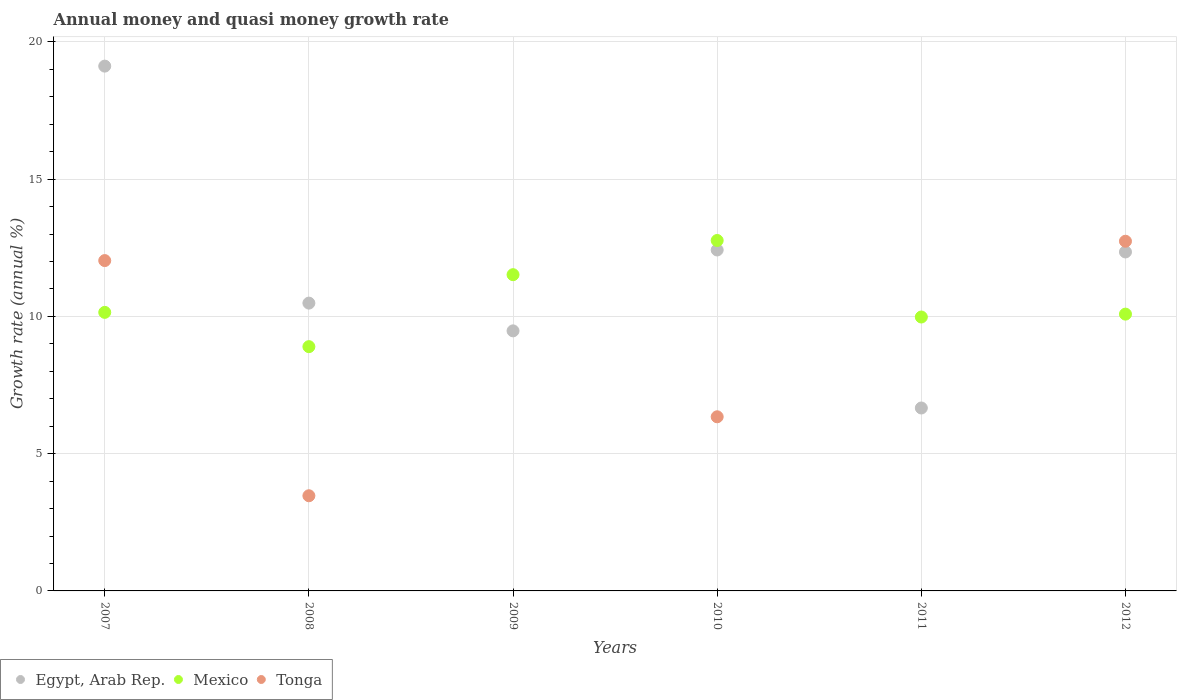Is the number of dotlines equal to the number of legend labels?
Ensure brevity in your answer.  No. What is the growth rate in Tonga in 2010?
Give a very brief answer. 6.34. Across all years, what is the maximum growth rate in Mexico?
Ensure brevity in your answer.  12.77. Across all years, what is the minimum growth rate in Mexico?
Make the answer very short. 8.9. What is the total growth rate in Tonga in the graph?
Make the answer very short. 34.58. What is the difference between the growth rate in Mexico in 2009 and that in 2012?
Provide a short and direct response. 1.44. What is the difference between the growth rate in Tonga in 2011 and the growth rate in Mexico in 2012?
Provide a succinct answer. -10.08. What is the average growth rate in Tonga per year?
Offer a terse response. 5.76. In the year 2007, what is the difference between the growth rate in Egypt, Arab Rep. and growth rate in Tonga?
Your answer should be compact. 7.08. In how many years, is the growth rate in Tonga greater than 12 %?
Ensure brevity in your answer.  2. What is the ratio of the growth rate in Mexico in 2009 to that in 2012?
Ensure brevity in your answer.  1.14. Is the growth rate in Mexico in 2007 less than that in 2008?
Offer a terse response. No. Is the difference between the growth rate in Egypt, Arab Rep. in 2007 and 2010 greater than the difference between the growth rate in Tonga in 2007 and 2010?
Provide a short and direct response. Yes. What is the difference between the highest and the second highest growth rate in Egypt, Arab Rep.?
Make the answer very short. 6.7. What is the difference between the highest and the lowest growth rate in Tonga?
Provide a succinct answer. 12.74. How many dotlines are there?
Give a very brief answer. 3. What is the difference between two consecutive major ticks on the Y-axis?
Offer a very short reply. 5. Are the values on the major ticks of Y-axis written in scientific E-notation?
Your answer should be very brief. No. Does the graph contain grids?
Make the answer very short. Yes. How are the legend labels stacked?
Give a very brief answer. Horizontal. What is the title of the graph?
Keep it short and to the point. Annual money and quasi money growth rate. Does "Greenland" appear as one of the legend labels in the graph?
Make the answer very short. No. What is the label or title of the X-axis?
Offer a very short reply. Years. What is the label or title of the Y-axis?
Provide a short and direct response. Growth rate (annual %). What is the Growth rate (annual %) in Egypt, Arab Rep. in 2007?
Make the answer very short. 19.12. What is the Growth rate (annual %) of Mexico in 2007?
Your response must be concise. 10.15. What is the Growth rate (annual %) of Tonga in 2007?
Your answer should be very brief. 12.03. What is the Growth rate (annual %) in Egypt, Arab Rep. in 2008?
Offer a very short reply. 10.49. What is the Growth rate (annual %) of Mexico in 2008?
Offer a terse response. 8.9. What is the Growth rate (annual %) in Tonga in 2008?
Your response must be concise. 3.47. What is the Growth rate (annual %) in Egypt, Arab Rep. in 2009?
Make the answer very short. 9.47. What is the Growth rate (annual %) in Mexico in 2009?
Offer a very short reply. 11.52. What is the Growth rate (annual %) of Tonga in 2009?
Keep it short and to the point. 0. What is the Growth rate (annual %) in Egypt, Arab Rep. in 2010?
Provide a succinct answer. 12.42. What is the Growth rate (annual %) of Mexico in 2010?
Give a very brief answer. 12.77. What is the Growth rate (annual %) in Tonga in 2010?
Your response must be concise. 6.34. What is the Growth rate (annual %) in Egypt, Arab Rep. in 2011?
Offer a terse response. 6.66. What is the Growth rate (annual %) of Mexico in 2011?
Your answer should be very brief. 9.98. What is the Growth rate (annual %) of Egypt, Arab Rep. in 2012?
Your response must be concise. 12.35. What is the Growth rate (annual %) in Mexico in 2012?
Give a very brief answer. 10.08. What is the Growth rate (annual %) in Tonga in 2012?
Your response must be concise. 12.74. Across all years, what is the maximum Growth rate (annual %) of Egypt, Arab Rep.?
Your answer should be very brief. 19.12. Across all years, what is the maximum Growth rate (annual %) of Mexico?
Give a very brief answer. 12.77. Across all years, what is the maximum Growth rate (annual %) in Tonga?
Provide a succinct answer. 12.74. Across all years, what is the minimum Growth rate (annual %) in Egypt, Arab Rep.?
Your answer should be compact. 6.66. Across all years, what is the minimum Growth rate (annual %) of Mexico?
Your answer should be very brief. 8.9. Across all years, what is the minimum Growth rate (annual %) of Tonga?
Your response must be concise. 0. What is the total Growth rate (annual %) of Egypt, Arab Rep. in the graph?
Provide a short and direct response. 70.51. What is the total Growth rate (annual %) of Mexico in the graph?
Provide a succinct answer. 63.4. What is the total Growth rate (annual %) in Tonga in the graph?
Ensure brevity in your answer.  34.58. What is the difference between the Growth rate (annual %) in Egypt, Arab Rep. in 2007 and that in 2008?
Provide a succinct answer. 8.63. What is the difference between the Growth rate (annual %) in Mexico in 2007 and that in 2008?
Provide a succinct answer. 1.25. What is the difference between the Growth rate (annual %) of Tonga in 2007 and that in 2008?
Ensure brevity in your answer.  8.57. What is the difference between the Growth rate (annual %) in Egypt, Arab Rep. in 2007 and that in 2009?
Your answer should be compact. 9.65. What is the difference between the Growth rate (annual %) in Mexico in 2007 and that in 2009?
Your answer should be compact. -1.37. What is the difference between the Growth rate (annual %) in Egypt, Arab Rep. in 2007 and that in 2010?
Your response must be concise. 6.7. What is the difference between the Growth rate (annual %) of Mexico in 2007 and that in 2010?
Make the answer very short. -2.62. What is the difference between the Growth rate (annual %) of Tonga in 2007 and that in 2010?
Offer a terse response. 5.69. What is the difference between the Growth rate (annual %) of Egypt, Arab Rep. in 2007 and that in 2011?
Your answer should be very brief. 12.45. What is the difference between the Growth rate (annual %) of Mexico in 2007 and that in 2011?
Give a very brief answer. 0.17. What is the difference between the Growth rate (annual %) of Egypt, Arab Rep. in 2007 and that in 2012?
Give a very brief answer. 6.77. What is the difference between the Growth rate (annual %) in Mexico in 2007 and that in 2012?
Keep it short and to the point. 0.06. What is the difference between the Growth rate (annual %) in Tonga in 2007 and that in 2012?
Your response must be concise. -0.7. What is the difference between the Growth rate (annual %) in Egypt, Arab Rep. in 2008 and that in 2009?
Keep it short and to the point. 1.01. What is the difference between the Growth rate (annual %) in Mexico in 2008 and that in 2009?
Provide a succinct answer. -2.62. What is the difference between the Growth rate (annual %) in Egypt, Arab Rep. in 2008 and that in 2010?
Your answer should be compact. -1.94. What is the difference between the Growth rate (annual %) in Mexico in 2008 and that in 2010?
Your response must be concise. -3.87. What is the difference between the Growth rate (annual %) of Tonga in 2008 and that in 2010?
Keep it short and to the point. -2.88. What is the difference between the Growth rate (annual %) of Egypt, Arab Rep. in 2008 and that in 2011?
Give a very brief answer. 3.82. What is the difference between the Growth rate (annual %) in Mexico in 2008 and that in 2011?
Offer a very short reply. -1.08. What is the difference between the Growth rate (annual %) of Egypt, Arab Rep. in 2008 and that in 2012?
Your answer should be compact. -1.86. What is the difference between the Growth rate (annual %) of Mexico in 2008 and that in 2012?
Make the answer very short. -1.19. What is the difference between the Growth rate (annual %) of Tonga in 2008 and that in 2012?
Provide a short and direct response. -9.27. What is the difference between the Growth rate (annual %) of Egypt, Arab Rep. in 2009 and that in 2010?
Offer a terse response. -2.95. What is the difference between the Growth rate (annual %) in Mexico in 2009 and that in 2010?
Your response must be concise. -1.25. What is the difference between the Growth rate (annual %) in Egypt, Arab Rep. in 2009 and that in 2011?
Offer a terse response. 2.81. What is the difference between the Growth rate (annual %) of Mexico in 2009 and that in 2011?
Provide a succinct answer. 1.54. What is the difference between the Growth rate (annual %) in Egypt, Arab Rep. in 2009 and that in 2012?
Ensure brevity in your answer.  -2.87. What is the difference between the Growth rate (annual %) in Mexico in 2009 and that in 2012?
Make the answer very short. 1.44. What is the difference between the Growth rate (annual %) of Egypt, Arab Rep. in 2010 and that in 2011?
Offer a very short reply. 5.76. What is the difference between the Growth rate (annual %) in Mexico in 2010 and that in 2011?
Your response must be concise. 2.79. What is the difference between the Growth rate (annual %) of Egypt, Arab Rep. in 2010 and that in 2012?
Ensure brevity in your answer.  0.07. What is the difference between the Growth rate (annual %) of Mexico in 2010 and that in 2012?
Provide a short and direct response. 2.68. What is the difference between the Growth rate (annual %) of Tonga in 2010 and that in 2012?
Offer a very short reply. -6.4. What is the difference between the Growth rate (annual %) of Egypt, Arab Rep. in 2011 and that in 2012?
Offer a terse response. -5.68. What is the difference between the Growth rate (annual %) of Mexico in 2011 and that in 2012?
Offer a terse response. -0.1. What is the difference between the Growth rate (annual %) in Egypt, Arab Rep. in 2007 and the Growth rate (annual %) in Mexico in 2008?
Your answer should be very brief. 10.22. What is the difference between the Growth rate (annual %) of Egypt, Arab Rep. in 2007 and the Growth rate (annual %) of Tonga in 2008?
Make the answer very short. 15.65. What is the difference between the Growth rate (annual %) in Mexico in 2007 and the Growth rate (annual %) in Tonga in 2008?
Offer a very short reply. 6.68. What is the difference between the Growth rate (annual %) of Egypt, Arab Rep. in 2007 and the Growth rate (annual %) of Mexico in 2009?
Offer a terse response. 7.6. What is the difference between the Growth rate (annual %) of Egypt, Arab Rep. in 2007 and the Growth rate (annual %) of Mexico in 2010?
Make the answer very short. 6.35. What is the difference between the Growth rate (annual %) of Egypt, Arab Rep. in 2007 and the Growth rate (annual %) of Tonga in 2010?
Offer a terse response. 12.78. What is the difference between the Growth rate (annual %) in Mexico in 2007 and the Growth rate (annual %) in Tonga in 2010?
Your answer should be compact. 3.8. What is the difference between the Growth rate (annual %) in Egypt, Arab Rep. in 2007 and the Growth rate (annual %) in Mexico in 2011?
Ensure brevity in your answer.  9.14. What is the difference between the Growth rate (annual %) of Egypt, Arab Rep. in 2007 and the Growth rate (annual %) of Mexico in 2012?
Your answer should be compact. 9.04. What is the difference between the Growth rate (annual %) of Egypt, Arab Rep. in 2007 and the Growth rate (annual %) of Tonga in 2012?
Provide a succinct answer. 6.38. What is the difference between the Growth rate (annual %) in Mexico in 2007 and the Growth rate (annual %) in Tonga in 2012?
Offer a very short reply. -2.59. What is the difference between the Growth rate (annual %) of Egypt, Arab Rep. in 2008 and the Growth rate (annual %) of Mexico in 2009?
Offer a terse response. -1.04. What is the difference between the Growth rate (annual %) in Egypt, Arab Rep. in 2008 and the Growth rate (annual %) in Mexico in 2010?
Your answer should be very brief. -2.28. What is the difference between the Growth rate (annual %) in Egypt, Arab Rep. in 2008 and the Growth rate (annual %) in Tonga in 2010?
Offer a terse response. 4.14. What is the difference between the Growth rate (annual %) of Mexico in 2008 and the Growth rate (annual %) of Tonga in 2010?
Keep it short and to the point. 2.56. What is the difference between the Growth rate (annual %) in Egypt, Arab Rep. in 2008 and the Growth rate (annual %) in Mexico in 2011?
Provide a short and direct response. 0.51. What is the difference between the Growth rate (annual %) of Egypt, Arab Rep. in 2008 and the Growth rate (annual %) of Mexico in 2012?
Your answer should be compact. 0.4. What is the difference between the Growth rate (annual %) in Egypt, Arab Rep. in 2008 and the Growth rate (annual %) in Tonga in 2012?
Provide a succinct answer. -2.25. What is the difference between the Growth rate (annual %) of Mexico in 2008 and the Growth rate (annual %) of Tonga in 2012?
Provide a succinct answer. -3.84. What is the difference between the Growth rate (annual %) in Egypt, Arab Rep. in 2009 and the Growth rate (annual %) in Mexico in 2010?
Make the answer very short. -3.29. What is the difference between the Growth rate (annual %) of Egypt, Arab Rep. in 2009 and the Growth rate (annual %) of Tonga in 2010?
Offer a terse response. 3.13. What is the difference between the Growth rate (annual %) of Mexico in 2009 and the Growth rate (annual %) of Tonga in 2010?
Your answer should be very brief. 5.18. What is the difference between the Growth rate (annual %) of Egypt, Arab Rep. in 2009 and the Growth rate (annual %) of Mexico in 2011?
Ensure brevity in your answer.  -0.5. What is the difference between the Growth rate (annual %) of Egypt, Arab Rep. in 2009 and the Growth rate (annual %) of Mexico in 2012?
Give a very brief answer. -0.61. What is the difference between the Growth rate (annual %) in Egypt, Arab Rep. in 2009 and the Growth rate (annual %) in Tonga in 2012?
Your response must be concise. -3.27. What is the difference between the Growth rate (annual %) of Mexico in 2009 and the Growth rate (annual %) of Tonga in 2012?
Provide a short and direct response. -1.22. What is the difference between the Growth rate (annual %) of Egypt, Arab Rep. in 2010 and the Growth rate (annual %) of Mexico in 2011?
Your response must be concise. 2.44. What is the difference between the Growth rate (annual %) in Egypt, Arab Rep. in 2010 and the Growth rate (annual %) in Mexico in 2012?
Your response must be concise. 2.34. What is the difference between the Growth rate (annual %) in Egypt, Arab Rep. in 2010 and the Growth rate (annual %) in Tonga in 2012?
Your response must be concise. -0.32. What is the difference between the Growth rate (annual %) of Mexico in 2010 and the Growth rate (annual %) of Tonga in 2012?
Keep it short and to the point. 0.03. What is the difference between the Growth rate (annual %) of Egypt, Arab Rep. in 2011 and the Growth rate (annual %) of Mexico in 2012?
Provide a short and direct response. -3.42. What is the difference between the Growth rate (annual %) in Egypt, Arab Rep. in 2011 and the Growth rate (annual %) in Tonga in 2012?
Give a very brief answer. -6.07. What is the difference between the Growth rate (annual %) of Mexico in 2011 and the Growth rate (annual %) of Tonga in 2012?
Your answer should be compact. -2.76. What is the average Growth rate (annual %) in Egypt, Arab Rep. per year?
Offer a very short reply. 11.75. What is the average Growth rate (annual %) of Mexico per year?
Offer a terse response. 10.57. What is the average Growth rate (annual %) of Tonga per year?
Offer a terse response. 5.76. In the year 2007, what is the difference between the Growth rate (annual %) in Egypt, Arab Rep. and Growth rate (annual %) in Mexico?
Give a very brief answer. 8.97. In the year 2007, what is the difference between the Growth rate (annual %) of Egypt, Arab Rep. and Growth rate (annual %) of Tonga?
Your answer should be very brief. 7.08. In the year 2007, what is the difference between the Growth rate (annual %) of Mexico and Growth rate (annual %) of Tonga?
Your answer should be very brief. -1.89. In the year 2008, what is the difference between the Growth rate (annual %) of Egypt, Arab Rep. and Growth rate (annual %) of Mexico?
Ensure brevity in your answer.  1.59. In the year 2008, what is the difference between the Growth rate (annual %) in Egypt, Arab Rep. and Growth rate (annual %) in Tonga?
Offer a very short reply. 7.02. In the year 2008, what is the difference between the Growth rate (annual %) of Mexico and Growth rate (annual %) of Tonga?
Make the answer very short. 5.43. In the year 2009, what is the difference between the Growth rate (annual %) in Egypt, Arab Rep. and Growth rate (annual %) in Mexico?
Keep it short and to the point. -2.05. In the year 2010, what is the difference between the Growth rate (annual %) in Egypt, Arab Rep. and Growth rate (annual %) in Mexico?
Give a very brief answer. -0.35. In the year 2010, what is the difference between the Growth rate (annual %) of Egypt, Arab Rep. and Growth rate (annual %) of Tonga?
Offer a very short reply. 6.08. In the year 2010, what is the difference between the Growth rate (annual %) of Mexico and Growth rate (annual %) of Tonga?
Your response must be concise. 6.42. In the year 2011, what is the difference between the Growth rate (annual %) of Egypt, Arab Rep. and Growth rate (annual %) of Mexico?
Give a very brief answer. -3.31. In the year 2012, what is the difference between the Growth rate (annual %) of Egypt, Arab Rep. and Growth rate (annual %) of Mexico?
Offer a terse response. 2.26. In the year 2012, what is the difference between the Growth rate (annual %) of Egypt, Arab Rep. and Growth rate (annual %) of Tonga?
Provide a succinct answer. -0.39. In the year 2012, what is the difference between the Growth rate (annual %) of Mexico and Growth rate (annual %) of Tonga?
Provide a short and direct response. -2.66. What is the ratio of the Growth rate (annual %) of Egypt, Arab Rep. in 2007 to that in 2008?
Keep it short and to the point. 1.82. What is the ratio of the Growth rate (annual %) in Mexico in 2007 to that in 2008?
Provide a succinct answer. 1.14. What is the ratio of the Growth rate (annual %) of Tonga in 2007 to that in 2008?
Offer a very short reply. 3.47. What is the ratio of the Growth rate (annual %) of Egypt, Arab Rep. in 2007 to that in 2009?
Your response must be concise. 2.02. What is the ratio of the Growth rate (annual %) of Mexico in 2007 to that in 2009?
Your answer should be very brief. 0.88. What is the ratio of the Growth rate (annual %) of Egypt, Arab Rep. in 2007 to that in 2010?
Make the answer very short. 1.54. What is the ratio of the Growth rate (annual %) of Mexico in 2007 to that in 2010?
Provide a short and direct response. 0.79. What is the ratio of the Growth rate (annual %) of Tonga in 2007 to that in 2010?
Keep it short and to the point. 1.9. What is the ratio of the Growth rate (annual %) of Egypt, Arab Rep. in 2007 to that in 2011?
Your answer should be very brief. 2.87. What is the ratio of the Growth rate (annual %) in Mexico in 2007 to that in 2011?
Your answer should be very brief. 1.02. What is the ratio of the Growth rate (annual %) of Egypt, Arab Rep. in 2007 to that in 2012?
Offer a terse response. 1.55. What is the ratio of the Growth rate (annual %) of Mexico in 2007 to that in 2012?
Give a very brief answer. 1.01. What is the ratio of the Growth rate (annual %) of Tonga in 2007 to that in 2012?
Keep it short and to the point. 0.94. What is the ratio of the Growth rate (annual %) in Egypt, Arab Rep. in 2008 to that in 2009?
Ensure brevity in your answer.  1.11. What is the ratio of the Growth rate (annual %) of Mexico in 2008 to that in 2009?
Ensure brevity in your answer.  0.77. What is the ratio of the Growth rate (annual %) of Egypt, Arab Rep. in 2008 to that in 2010?
Give a very brief answer. 0.84. What is the ratio of the Growth rate (annual %) in Mexico in 2008 to that in 2010?
Give a very brief answer. 0.7. What is the ratio of the Growth rate (annual %) in Tonga in 2008 to that in 2010?
Ensure brevity in your answer.  0.55. What is the ratio of the Growth rate (annual %) in Egypt, Arab Rep. in 2008 to that in 2011?
Offer a terse response. 1.57. What is the ratio of the Growth rate (annual %) of Mexico in 2008 to that in 2011?
Keep it short and to the point. 0.89. What is the ratio of the Growth rate (annual %) of Egypt, Arab Rep. in 2008 to that in 2012?
Provide a short and direct response. 0.85. What is the ratio of the Growth rate (annual %) of Mexico in 2008 to that in 2012?
Give a very brief answer. 0.88. What is the ratio of the Growth rate (annual %) of Tonga in 2008 to that in 2012?
Keep it short and to the point. 0.27. What is the ratio of the Growth rate (annual %) of Egypt, Arab Rep. in 2009 to that in 2010?
Keep it short and to the point. 0.76. What is the ratio of the Growth rate (annual %) of Mexico in 2009 to that in 2010?
Your response must be concise. 0.9. What is the ratio of the Growth rate (annual %) in Egypt, Arab Rep. in 2009 to that in 2011?
Your response must be concise. 1.42. What is the ratio of the Growth rate (annual %) of Mexico in 2009 to that in 2011?
Make the answer very short. 1.15. What is the ratio of the Growth rate (annual %) in Egypt, Arab Rep. in 2009 to that in 2012?
Ensure brevity in your answer.  0.77. What is the ratio of the Growth rate (annual %) in Mexico in 2009 to that in 2012?
Make the answer very short. 1.14. What is the ratio of the Growth rate (annual %) in Egypt, Arab Rep. in 2010 to that in 2011?
Offer a very short reply. 1.86. What is the ratio of the Growth rate (annual %) of Mexico in 2010 to that in 2011?
Your answer should be very brief. 1.28. What is the ratio of the Growth rate (annual %) of Mexico in 2010 to that in 2012?
Keep it short and to the point. 1.27. What is the ratio of the Growth rate (annual %) of Tonga in 2010 to that in 2012?
Make the answer very short. 0.5. What is the ratio of the Growth rate (annual %) of Egypt, Arab Rep. in 2011 to that in 2012?
Offer a terse response. 0.54. What is the ratio of the Growth rate (annual %) of Mexico in 2011 to that in 2012?
Offer a very short reply. 0.99. What is the difference between the highest and the second highest Growth rate (annual %) in Egypt, Arab Rep.?
Ensure brevity in your answer.  6.7. What is the difference between the highest and the second highest Growth rate (annual %) in Mexico?
Provide a succinct answer. 1.25. What is the difference between the highest and the second highest Growth rate (annual %) in Tonga?
Your answer should be compact. 0.7. What is the difference between the highest and the lowest Growth rate (annual %) in Egypt, Arab Rep.?
Your answer should be very brief. 12.45. What is the difference between the highest and the lowest Growth rate (annual %) of Mexico?
Give a very brief answer. 3.87. What is the difference between the highest and the lowest Growth rate (annual %) of Tonga?
Offer a very short reply. 12.74. 